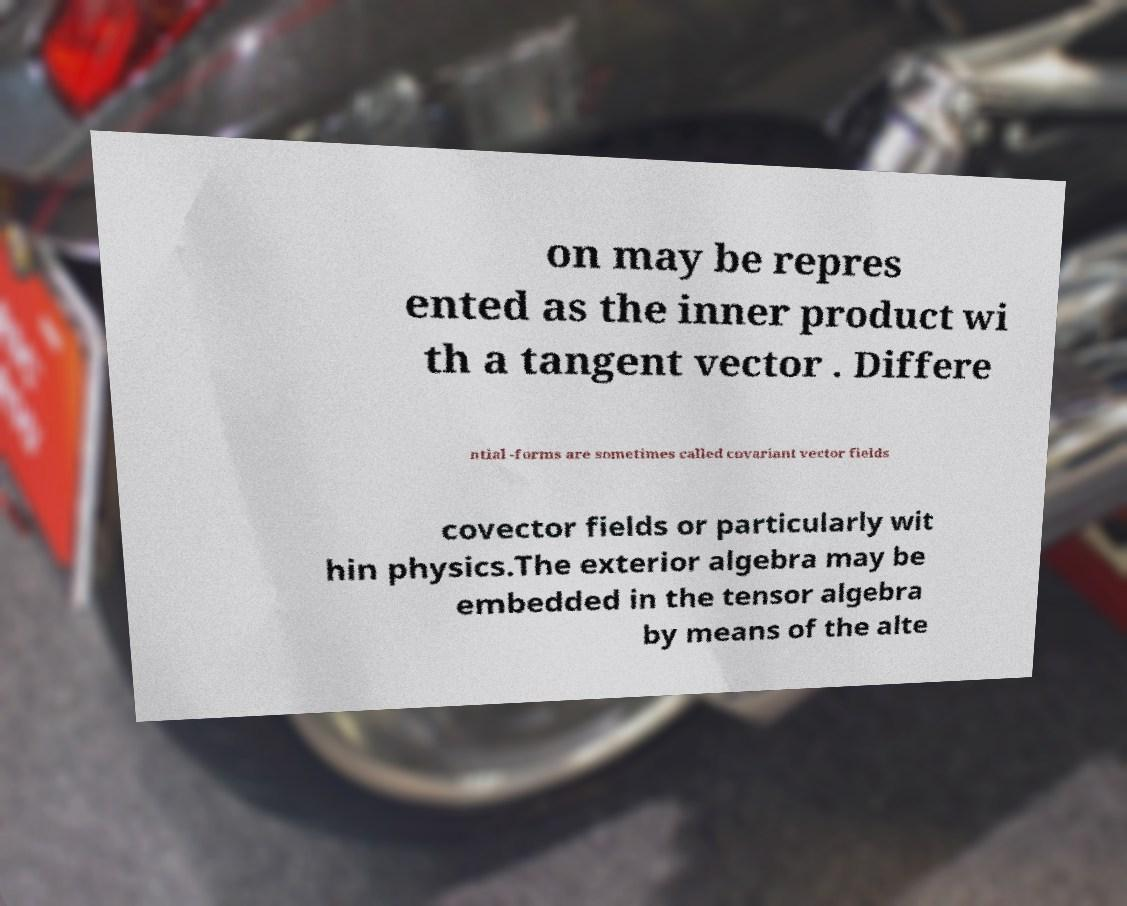Could you assist in decoding the text presented in this image and type it out clearly? on may be repres ented as the inner product wi th a tangent vector . Differe ntial -forms are sometimes called covariant vector fields covector fields or particularly wit hin physics.The exterior algebra may be embedded in the tensor algebra by means of the alte 